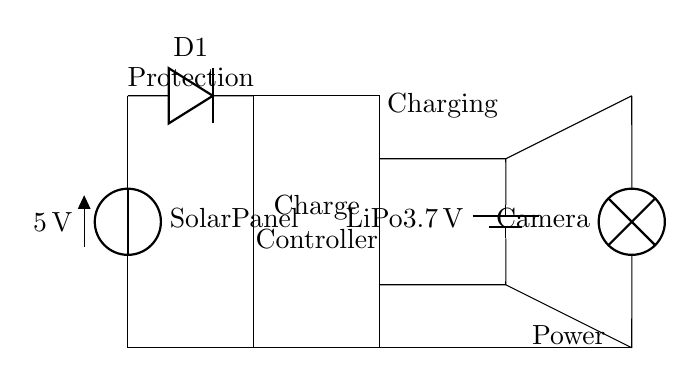What is the voltage of the solar panel? The voltage of the solar panel is indicated as 5 volts in the circuit diagram. This value is directly labeled next to the solar panel symbol.
Answer: 5 volts What type of diode is used in the circuit? The circuit diagram labels the diode as D1. This identifier helps understand its role in protecting the circuit from reverse voltage, which is a common function of diodes.
Answer: D1 What is the capacity of the battery? The battery in the circuit is labeled as a LiPo battery with a voltage of 3.7 volts. This specification indicates the type of battery and its nominal voltage.
Answer: 3.7 volts How many main components are in the circuit? The circuit consists of four main components: a solar panel, a diode, a charge controller, and a battery. These components are visually distinct and labeled in the circuit.
Answer: Four Why is there a charge controller in the circuit? A charge controller is used to regulate the charging of the battery from the solar panel. It prevents overcharging and maintains battery health, which is crucial for portable applications.
Answer: To regulate charging What is the purpose of the diode in this circuit? The diode is used to ensure that current flows in only one direction, protecting the circuit from potential damage caused by reverse current from the battery toward the solar panel when not in sunlight.
Answer: To prevent reverse current What loads can be powered by this circuit? The circuit diagram specifies a camera as the load, indicating that this solar-powered battery charging circuit is designed to provide power specifically for a portable camera.
Answer: Camera 